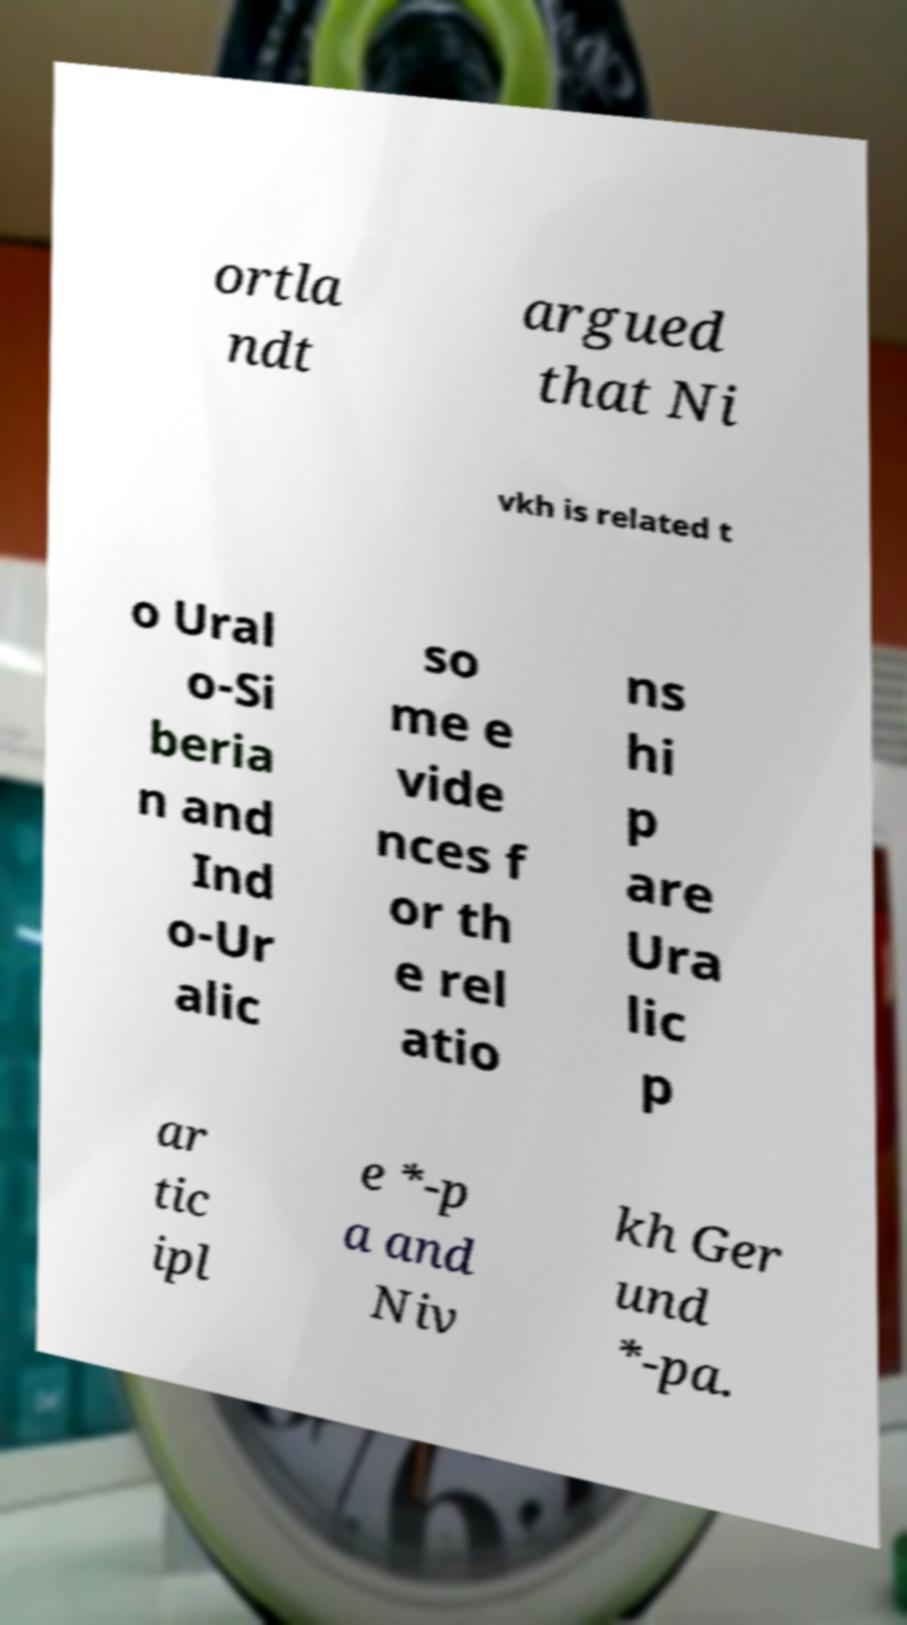Please identify and transcribe the text found in this image. ortla ndt argued that Ni vkh is related t o Ural o-Si beria n and Ind o-Ur alic so me e vide nces f or th e rel atio ns hi p are Ura lic p ar tic ipl e *-p a and Niv kh Ger und *-pa. 